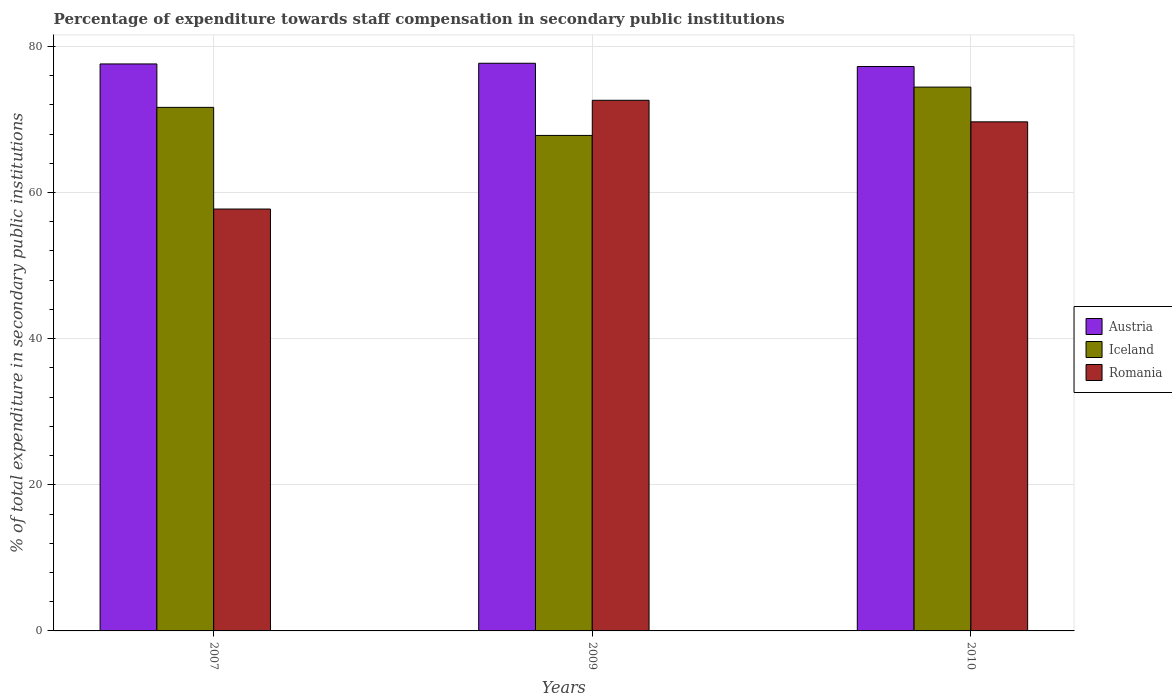How many groups of bars are there?
Offer a terse response. 3. Are the number of bars on each tick of the X-axis equal?
Your response must be concise. Yes. How many bars are there on the 3rd tick from the left?
Ensure brevity in your answer.  3. How many bars are there on the 3rd tick from the right?
Provide a short and direct response. 3. In how many cases, is the number of bars for a given year not equal to the number of legend labels?
Provide a succinct answer. 0. What is the percentage of expenditure towards staff compensation in Austria in 2007?
Your answer should be very brief. 77.59. Across all years, what is the maximum percentage of expenditure towards staff compensation in Iceland?
Your answer should be compact. 74.42. Across all years, what is the minimum percentage of expenditure towards staff compensation in Romania?
Give a very brief answer. 57.73. In which year was the percentage of expenditure towards staff compensation in Austria maximum?
Make the answer very short. 2009. In which year was the percentage of expenditure towards staff compensation in Iceland minimum?
Offer a very short reply. 2009. What is the total percentage of expenditure towards staff compensation in Austria in the graph?
Provide a succinct answer. 232.51. What is the difference between the percentage of expenditure towards staff compensation in Iceland in 2007 and that in 2010?
Your answer should be compact. -2.78. What is the difference between the percentage of expenditure towards staff compensation in Romania in 2007 and the percentage of expenditure towards staff compensation in Iceland in 2009?
Your answer should be very brief. -10.07. What is the average percentage of expenditure towards staff compensation in Austria per year?
Offer a terse response. 77.5. In the year 2009, what is the difference between the percentage of expenditure towards staff compensation in Romania and percentage of expenditure towards staff compensation in Austria?
Provide a short and direct response. -5.07. In how many years, is the percentage of expenditure towards staff compensation in Iceland greater than 64 %?
Your answer should be very brief. 3. What is the ratio of the percentage of expenditure towards staff compensation in Iceland in 2007 to that in 2009?
Your answer should be compact. 1.06. Is the difference between the percentage of expenditure towards staff compensation in Romania in 2009 and 2010 greater than the difference between the percentage of expenditure towards staff compensation in Austria in 2009 and 2010?
Ensure brevity in your answer.  Yes. What is the difference between the highest and the second highest percentage of expenditure towards staff compensation in Romania?
Provide a succinct answer. 2.95. What is the difference between the highest and the lowest percentage of expenditure towards staff compensation in Romania?
Give a very brief answer. 14.88. Is the sum of the percentage of expenditure towards staff compensation in Romania in 2007 and 2010 greater than the maximum percentage of expenditure towards staff compensation in Iceland across all years?
Keep it short and to the point. Yes. What does the 1st bar from the right in 2010 represents?
Provide a short and direct response. Romania. Is it the case that in every year, the sum of the percentage of expenditure towards staff compensation in Iceland and percentage of expenditure towards staff compensation in Austria is greater than the percentage of expenditure towards staff compensation in Romania?
Your answer should be very brief. Yes. How many bars are there?
Ensure brevity in your answer.  9. Are all the bars in the graph horizontal?
Provide a succinct answer. No. What is the difference between two consecutive major ticks on the Y-axis?
Your answer should be very brief. 20. Are the values on the major ticks of Y-axis written in scientific E-notation?
Make the answer very short. No. How many legend labels are there?
Provide a succinct answer. 3. How are the legend labels stacked?
Ensure brevity in your answer.  Vertical. What is the title of the graph?
Give a very brief answer. Percentage of expenditure towards staff compensation in secondary public institutions. Does "Samoa" appear as one of the legend labels in the graph?
Provide a succinct answer. No. What is the label or title of the X-axis?
Your answer should be very brief. Years. What is the label or title of the Y-axis?
Offer a terse response. % of total expenditure in secondary public institutions. What is the % of total expenditure in secondary public institutions in Austria in 2007?
Make the answer very short. 77.59. What is the % of total expenditure in secondary public institutions in Iceland in 2007?
Ensure brevity in your answer.  71.65. What is the % of total expenditure in secondary public institutions of Romania in 2007?
Keep it short and to the point. 57.73. What is the % of total expenditure in secondary public institutions in Austria in 2009?
Provide a succinct answer. 77.68. What is the % of total expenditure in secondary public institutions in Iceland in 2009?
Your answer should be very brief. 67.81. What is the % of total expenditure in secondary public institutions of Romania in 2009?
Keep it short and to the point. 72.62. What is the % of total expenditure in secondary public institutions of Austria in 2010?
Your answer should be compact. 77.24. What is the % of total expenditure in secondary public institutions of Iceland in 2010?
Offer a very short reply. 74.42. What is the % of total expenditure in secondary public institutions of Romania in 2010?
Make the answer very short. 69.67. Across all years, what is the maximum % of total expenditure in secondary public institutions in Austria?
Ensure brevity in your answer.  77.68. Across all years, what is the maximum % of total expenditure in secondary public institutions in Iceland?
Offer a terse response. 74.42. Across all years, what is the maximum % of total expenditure in secondary public institutions of Romania?
Ensure brevity in your answer.  72.62. Across all years, what is the minimum % of total expenditure in secondary public institutions in Austria?
Keep it short and to the point. 77.24. Across all years, what is the minimum % of total expenditure in secondary public institutions of Iceland?
Provide a succinct answer. 67.81. Across all years, what is the minimum % of total expenditure in secondary public institutions in Romania?
Offer a terse response. 57.73. What is the total % of total expenditure in secondary public institutions in Austria in the graph?
Your response must be concise. 232.51. What is the total % of total expenditure in secondary public institutions of Iceland in the graph?
Offer a very short reply. 213.88. What is the total % of total expenditure in secondary public institutions of Romania in the graph?
Provide a succinct answer. 200.02. What is the difference between the % of total expenditure in secondary public institutions in Austria in 2007 and that in 2009?
Your response must be concise. -0.09. What is the difference between the % of total expenditure in secondary public institutions in Iceland in 2007 and that in 2009?
Provide a succinct answer. 3.84. What is the difference between the % of total expenditure in secondary public institutions in Romania in 2007 and that in 2009?
Your answer should be compact. -14.88. What is the difference between the % of total expenditure in secondary public institutions of Austria in 2007 and that in 2010?
Ensure brevity in your answer.  0.35. What is the difference between the % of total expenditure in secondary public institutions in Iceland in 2007 and that in 2010?
Ensure brevity in your answer.  -2.78. What is the difference between the % of total expenditure in secondary public institutions in Romania in 2007 and that in 2010?
Your answer should be compact. -11.93. What is the difference between the % of total expenditure in secondary public institutions of Austria in 2009 and that in 2010?
Your answer should be compact. 0.45. What is the difference between the % of total expenditure in secondary public institutions in Iceland in 2009 and that in 2010?
Provide a succinct answer. -6.62. What is the difference between the % of total expenditure in secondary public institutions in Romania in 2009 and that in 2010?
Ensure brevity in your answer.  2.95. What is the difference between the % of total expenditure in secondary public institutions in Austria in 2007 and the % of total expenditure in secondary public institutions in Iceland in 2009?
Your answer should be compact. 9.78. What is the difference between the % of total expenditure in secondary public institutions of Austria in 2007 and the % of total expenditure in secondary public institutions of Romania in 2009?
Your response must be concise. 4.97. What is the difference between the % of total expenditure in secondary public institutions of Iceland in 2007 and the % of total expenditure in secondary public institutions of Romania in 2009?
Provide a succinct answer. -0.97. What is the difference between the % of total expenditure in secondary public institutions of Austria in 2007 and the % of total expenditure in secondary public institutions of Iceland in 2010?
Make the answer very short. 3.17. What is the difference between the % of total expenditure in secondary public institutions of Austria in 2007 and the % of total expenditure in secondary public institutions of Romania in 2010?
Your answer should be very brief. 7.92. What is the difference between the % of total expenditure in secondary public institutions in Iceland in 2007 and the % of total expenditure in secondary public institutions in Romania in 2010?
Provide a succinct answer. 1.98. What is the difference between the % of total expenditure in secondary public institutions in Austria in 2009 and the % of total expenditure in secondary public institutions in Iceland in 2010?
Your response must be concise. 3.26. What is the difference between the % of total expenditure in secondary public institutions in Austria in 2009 and the % of total expenditure in secondary public institutions in Romania in 2010?
Make the answer very short. 8.02. What is the difference between the % of total expenditure in secondary public institutions in Iceland in 2009 and the % of total expenditure in secondary public institutions in Romania in 2010?
Provide a short and direct response. -1.86. What is the average % of total expenditure in secondary public institutions of Austria per year?
Make the answer very short. 77.5. What is the average % of total expenditure in secondary public institutions of Iceland per year?
Give a very brief answer. 71.29. What is the average % of total expenditure in secondary public institutions of Romania per year?
Your answer should be very brief. 66.67. In the year 2007, what is the difference between the % of total expenditure in secondary public institutions in Austria and % of total expenditure in secondary public institutions in Iceland?
Give a very brief answer. 5.94. In the year 2007, what is the difference between the % of total expenditure in secondary public institutions of Austria and % of total expenditure in secondary public institutions of Romania?
Offer a very short reply. 19.86. In the year 2007, what is the difference between the % of total expenditure in secondary public institutions in Iceland and % of total expenditure in secondary public institutions in Romania?
Give a very brief answer. 13.91. In the year 2009, what is the difference between the % of total expenditure in secondary public institutions of Austria and % of total expenditure in secondary public institutions of Iceland?
Provide a short and direct response. 9.88. In the year 2009, what is the difference between the % of total expenditure in secondary public institutions in Austria and % of total expenditure in secondary public institutions in Romania?
Offer a terse response. 5.07. In the year 2009, what is the difference between the % of total expenditure in secondary public institutions in Iceland and % of total expenditure in secondary public institutions in Romania?
Your answer should be compact. -4.81. In the year 2010, what is the difference between the % of total expenditure in secondary public institutions in Austria and % of total expenditure in secondary public institutions in Iceland?
Offer a very short reply. 2.81. In the year 2010, what is the difference between the % of total expenditure in secondary public institutions in Austria and % of total expenditure in secondary public institutions in Romania?
Offer a terse response. 7.57. In the year 2010, what is the difference between the % of total expenditure in secondary public institutions in Iceland and % of total expenditure in secondary public institutions in Romania?
Provide a succinct answer. 4.76. What is the ratio of the % of total expenditure in secondary public institutions in Austria in 2007 to that in 2009?
Make the answer very short. 1. What is the ratio of the % of total expenditure in secondary public institutions of Iceland in 2007 to that in 2009?
Offer a terse response. 1.06. What is the ratio of the % of total expenditure in secondary public institutions of Romania in 2007 to that in 2009?
Give a very brief answer. 0.8. What is the ratio of the % of total expenditure in secondary public institutions of Iceland in 2007 to that in 2010?
Provide a short and direct response. 0.96. What is the ratio of the % of total expenditure in secondary public institutions in Romania in 2007 to that in 2010?
Keep it short and to the point. 0.83. What is the ratio of the % of total expenditure in secondary public institutions in Austria in 2009 to that in 2010?
Your answer should be very brief. 1.01. What is the ratio of the % of total expenditure in secondary public institutions in Iceland in 2009 to that in 2010?
Ensure brevity in your answer.  0.91. What is the ratio of the % of total expenditure in secondary public institutions of Romania in 2009 to that in 2010?
Your answer should be very brief. 1.04. What is the difference between the highest and the second highest % of total expenditure in secondary public institutions of Austria?
Keep it short and to the point. 0.09. What is the difference between the highest and the second highest % of total expenditure in secondary public institutions in Iceland?
Offer a very short reply. 2.78. What is the difference between the highest and the second highest % of total expenditure in secondary public institutions of Romania?
Your answer should be very brief. 2.95. What is the difference between the highest and the lowest % of total expenditure in secondary public institutions in Austria?
Your answer should be very brief. 0.45. What is the difference between the highest and the lowest % of total expenditure in secondary public institutions in Iceland?
Your response must be concise. 6.62. What is the difference between the highest and the lowest % of total expenditure in secondary public institutions of Romania?
Provide a short and direct response. 14.88. 